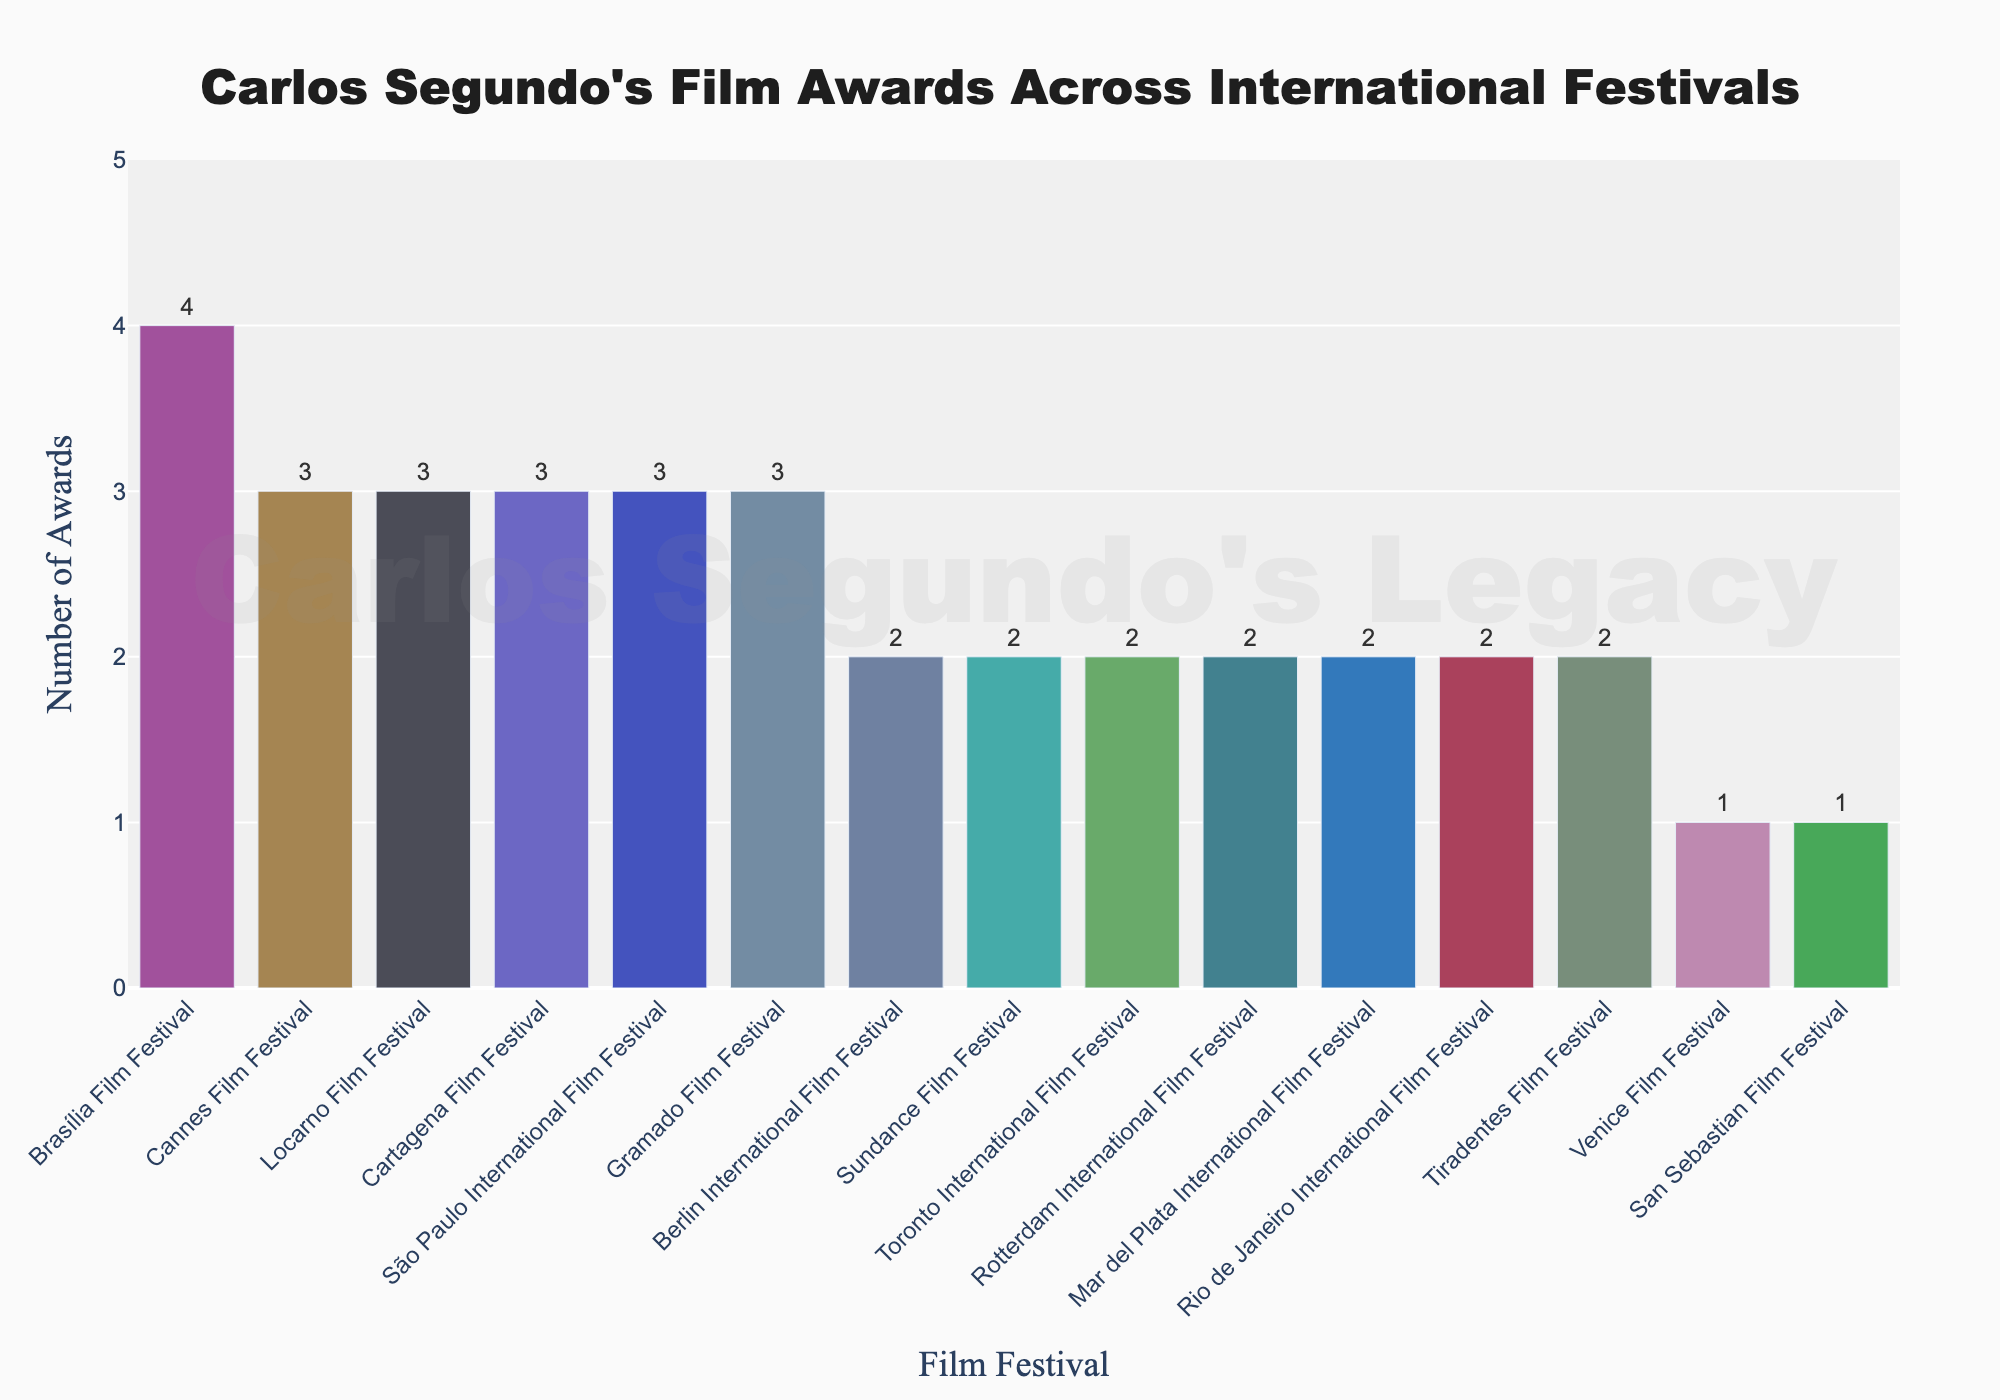What's the total number of awards won by Carlos Segundo's films across all festivals? To find the total, add up the number of awards from all listed festivals: 3 (Cannes) + 2 (Berlin) + 1 (Venice) + 2 (Sundance) + 2 (Toronto) + 3 (Locarno) + 2 (Rotterdam) + 1 (San Sebastian) + 2 (Mar del Plata) + 3 (Cartagena) + 4 (Brasília) + 3 (São Paulo) + 2 (Rio) + 3 (Gramado) + 2 (Tiradentes) = 35
Answer: 35 Which film festival awarded the highest number of awards to Carlos Segundo's films? Look for the festival with the tallest bar on the chart. Brasília Film Festival has the tallest bar with 4 awards.
Answer: Brasília Film Festival Which film festivals awarded exactly 2 awards to Carlos Segundo's films? Identify all bars with a height corresponding to 2 awards: Berlin International Film Festival, Sundance Film Festival, Toronto International Film Festival, Rotterdam International Film Festival, Mar del Plata International Film Festival, Rio de Janeiro International Film Festival, Tiradentes Film Festival.
Answer: Berlin, Sundance, Toronto, Rotterdam, Mar del Plata, Rio de Janeiro, Tiradentes How many more awards did Carlos Segundo's films win at the Cannes Film Festival compared to the Venice Film Festival? Subtract the number of awards at the Venice Film Festival (1) from the awards at the Cannes Film Festival (3): 3 - 1 = 2
Answer: 2 What's the average number of awards won across all festivals? Find the sum of all awards (35) and divide by the number of festivals (15): 35 / 15 ≈ 2.33
Answer: 2.33 Which festivals awarded an equal number of awards to Carlos Segundo's films? Identify the bars that have the same height. Berlin International Film Festival, Sundance Film Festival, Toronto International Film Festival, Rotterdam International Film Festival, Mar del Plata International Film Festival, Rio de Janeiro International Film Festival, and Tiradentes Film Festival all have 2 awards each. São Paulo, Cannes, Locarno, Cartagena, and Gramado all have 3 awards each.
Answer: Berlin, Sundance, Toronto, Rotterdam, Mar del Plata, Rio de Janeiro, Tiradentes (2 awards); São Paulo, Cannes, Locarno, Cartagena, Gramado (3 awards) How many festivals awarded more than 2 awards? Count the bars with heights greater than 2: Brasília (4), Cannes (3), Locarno (3), Cartagena (3), São Paulo (3), Gramado (3). There are 6 festivals.
Answer: 6 What's the combined number of awards won by Carlos Segundo's films at South American festivals? Summing the awards from Brasília (4), São Paulo (3), Rio de Janeiro (2), Gramado (3), Cartagena (3), Mar del Plata (2), results in 4 + 3 + 2 + 3 + 3 + 2 = 17
Answer: 17 Which European film festival awarded Carlos Segundo's films the most? Identify the European festivals and find the one with the highest awards. Cannes (3), Berlin (2), Venice (1), Locarno (3), Rotterdam (2), San Sebastian (1). Cannes and Locarno are tied with 3 awards each.
Answer: Cannes and Locarno 